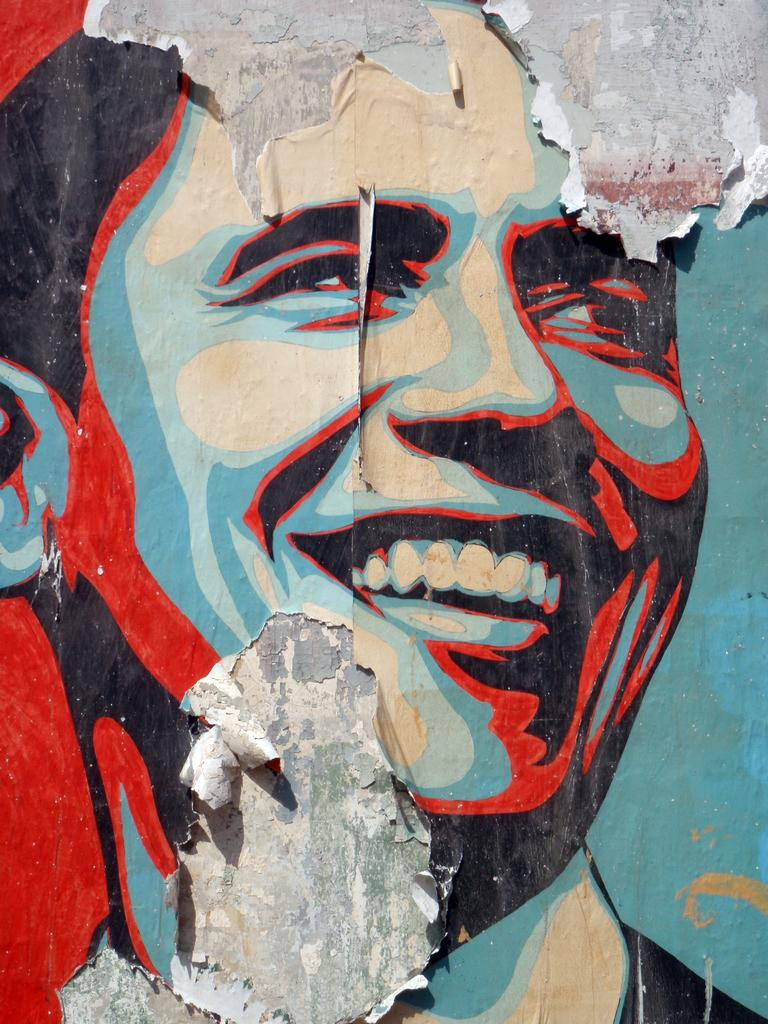What is the main subject of the wall painting in the image? The wall painting depicts a person. What colors are used in the wall painting? The colors used in the wall painting are black, blue, and red. What type of stew is being prepared in the image? There is no stew present in the image; it features a wall painting with a person as the main subject. What muscle is being exercised by the person in the wall painting? The image does not show the person exercising any muscles; it only depicts a person as the main subject. 